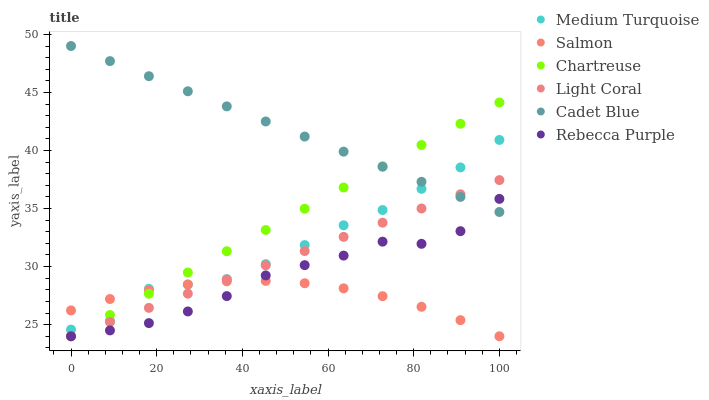Does Salmon have the minimum area under the curve?
Answer yes or no. Yes. Does Cadet Blue have the maximum area under the curve?
Answer yes or no. Yes. Does Light Coral have the minimum area under the curve?
Answer yes or no. No. Does Light Coral have the maximum area under the curve?
Answer yes or no. No. Is Cadet Blue the smoothest?
Answer yes or no. Yes. Is Medium Turquoise the roughest?
Answer yes or no. Yes. Is Salmon the smoothest?
Answer yes or no. No. Is Salmon the roughest?
Answer yes or no. No. Does Salmon have the lowest value?
Answer yes or no. Yes. Does Medium Turquoise have the lowest value?
Answer yes or no. No. Does Cadet Blue have the highest value?
Answer yes or no. Yes. Does Light Coral have the highest value?
Answer yes or no. No. Is Salmon less than Cadet Blue?
Answer yes or no. Yes. Is Cadet Blue greater than Salmon?
Answer yes or no. Yes. Does Light Coral intersect Rebecca Purple?
Answer yes or no. Yes. Is Light Coral less than Rebecca Purple?
Answer yes or no. No. Is Light Coral greater than Rebecca Purple?
Answer yes or no. No. Does Salmon intersect Cadet Blue?
Answer yes or no. No. 